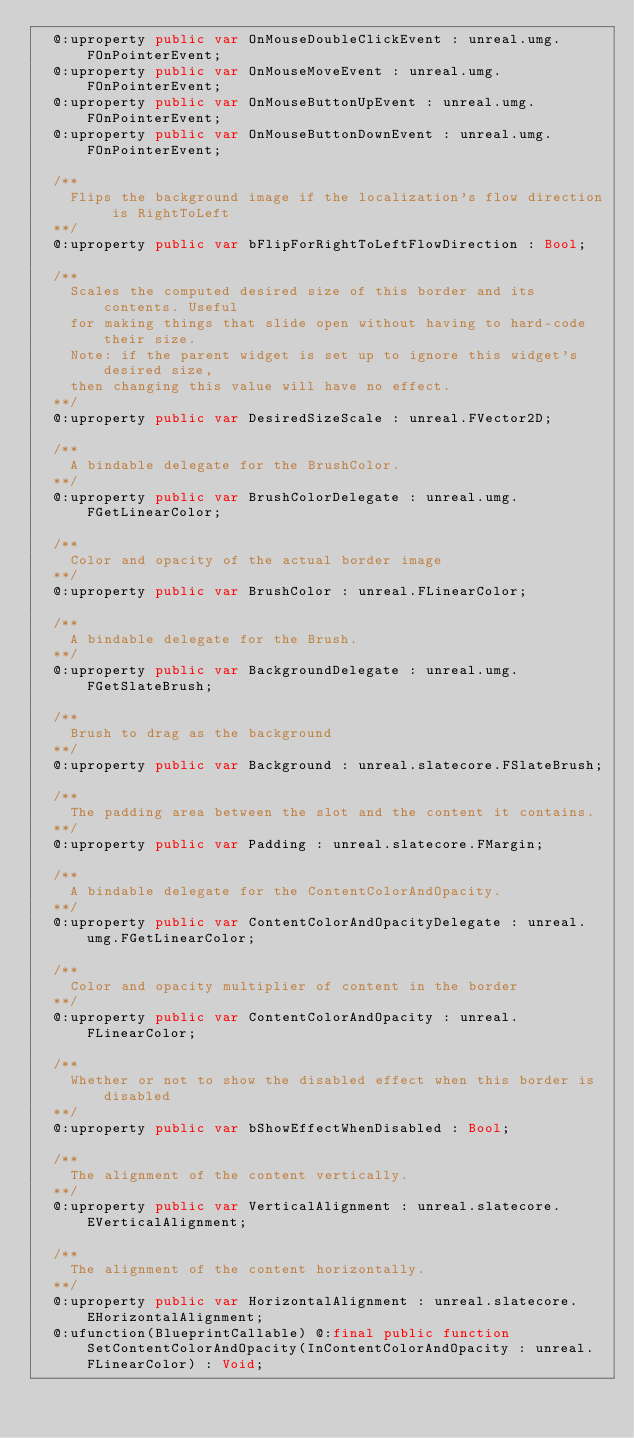<code> <loc_0><loc_0><loc_500><loc_500><_Haxe_>  @:uproperty public var OnMouseDoubleClickEvent : unreal.umg.FOnPointerEvent;
  @:uproperty public var OnMouseMoveEvent : unreal.umg.FOnPointerEvent;
  @:uproperty public var OnMouseButtonUpEvent : unreal.umg.FOnPointerEvent;
  @:uproperty public var OnMouseButtonDownEvent : unreal.umg.FOnPointerEvent;
  
  /**
    Flips the background image if the localization's flow direction is RightToLeft
  **/
  @:uproperty public var bFlipForRightToLeftFlowDirection : Bool;
  
  /**
    Scales the computed desired size of this border and its contents. Useful
    for making things that slide open without having to hard-code their size.
    Note: if the parent widget is set up to ignore this widget's desired size,
    then changing this value will have no effect.
  **/
  @:uproperty public var DesiredSizeScale : unreal.FVector2D;
  
  /**
    A bindable delegate for the BrushColor.
  **/
  @:uproperty public var BrushColorDelegate : unreal.umg.FGetLinearColor;
  
  /**
    Color and opacity of the actual border image
  **/
  @:uproperty public var BrushColor : unreal.FLinearColor;
  
  /**
    A bindable delegate for the Brush.
  **/
  @:uproperty public var BackgroundDelegate : unreal.umg.FGetSlateBrush;
  
  /**
    Brush to drag as the background
  **/
  @:uproperty public var Background : unreal.slatecore.FSlateBrush;
  
  /**
    The padding area between the slot and the content it contains.
  **/
  @:uproperty public var Padding : unreal.slatecore.FMargin;
  
  /**
    A bindable delegate for the ContentColorAndOpacity.
  **/
  @:uproperty public var ContentColorAndOpacityDelegate : unreal.umg.FGetLinearColor;
  
  /**
    Color and opacity multiplier of content in the border
  **/
  @:uproperty public var ContentColorAndOpacity : unreal.FLinearColor;
  
  /**
    Whether or not to show the disabled effect when this border is disabled
  **/
  @:uproperty public var bShowEffectWhenDisabled : Bool;
  
  /**
    The alignment of the content vertically.
  **/
  @:uproperty public var VerticalAlignment : unreal.slatecore.EVerticalAlignment;
  
  /**
    The alignment of the content horizontally.
  **/
  @:uproperty public var HorizontalAlignment : unreal.slatecore.EHorizontalAlignment;
  @:ufunction(BlueprintCallable) @:final public function SetContentColorAndOpacity(InContentColorAndOpacity : unreal.FLinearColor) : Void;</code> 